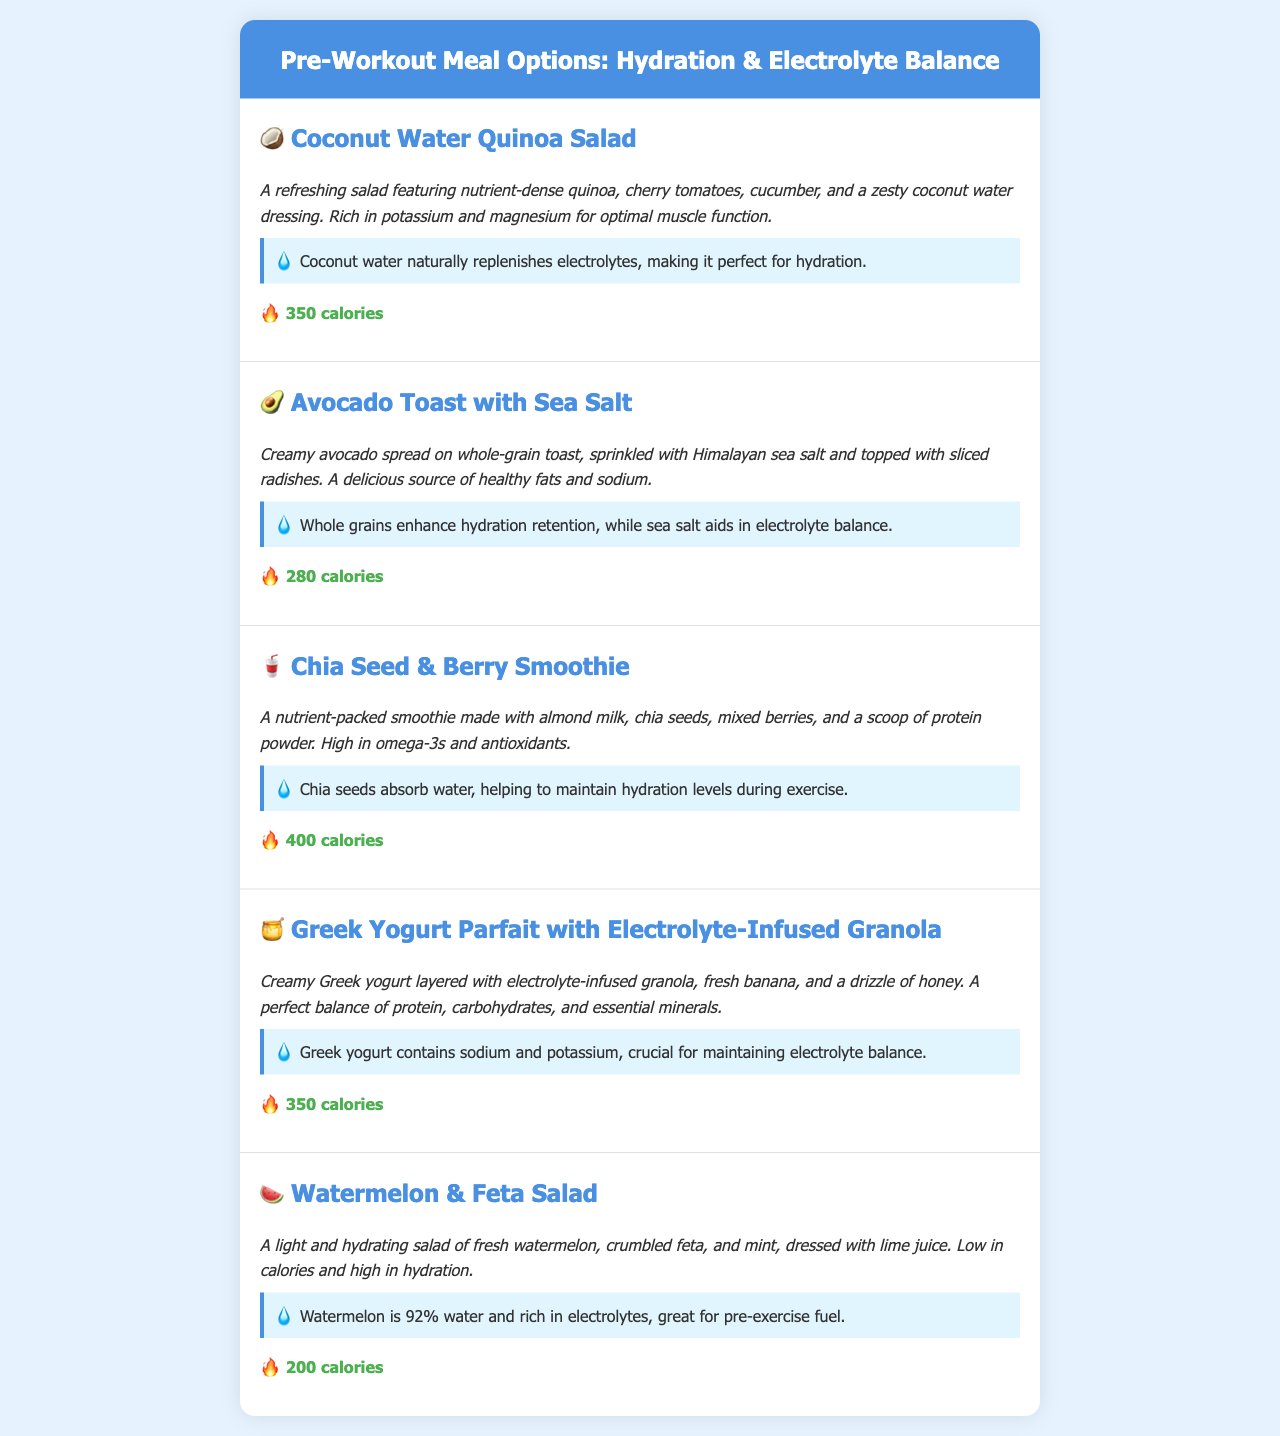What is the first menu item? The first menu item listed in the document is "Coconut Water Quinoa Salad."
Answer: Coconut Water Quinoa Salad How many calories does the Greek Yogurt Parfait contain? The document specifies that the Greek Yogurt Parfait has 350 calories.
Answer: 350 calories Which ingredient in the Avocado Toast aids in electrolyte balance? The document states that sea salt aids in electrolyte balance in the Avocado Toast.
Answer: Sea Salt What percentage of water is in watermelon? The document mentions that watermelon is 92% water.
Answer: 92% What is the main source of hydration in the Chia Seed & Berry Smoothie? The document indicates that chia seeds absorb water, helping to maintain hydration levels.
Answer: Chia seeds Which menu item has a zesty dressing? The Coconut Water Quinoa Salad features a zesty coconut water dressing.
Answer: Coconut Water Quinoa Salad How is the Watermelon & Feta Salad described in terms of calories? The document describes the Watermelon & Feta Salad as low in calories.
Answer: Low in calories What is the base for the Chia Seed & Berry Smoothie? The document specifies that almond milk is used as the base for the smoothie.
Answer: Almond milk 